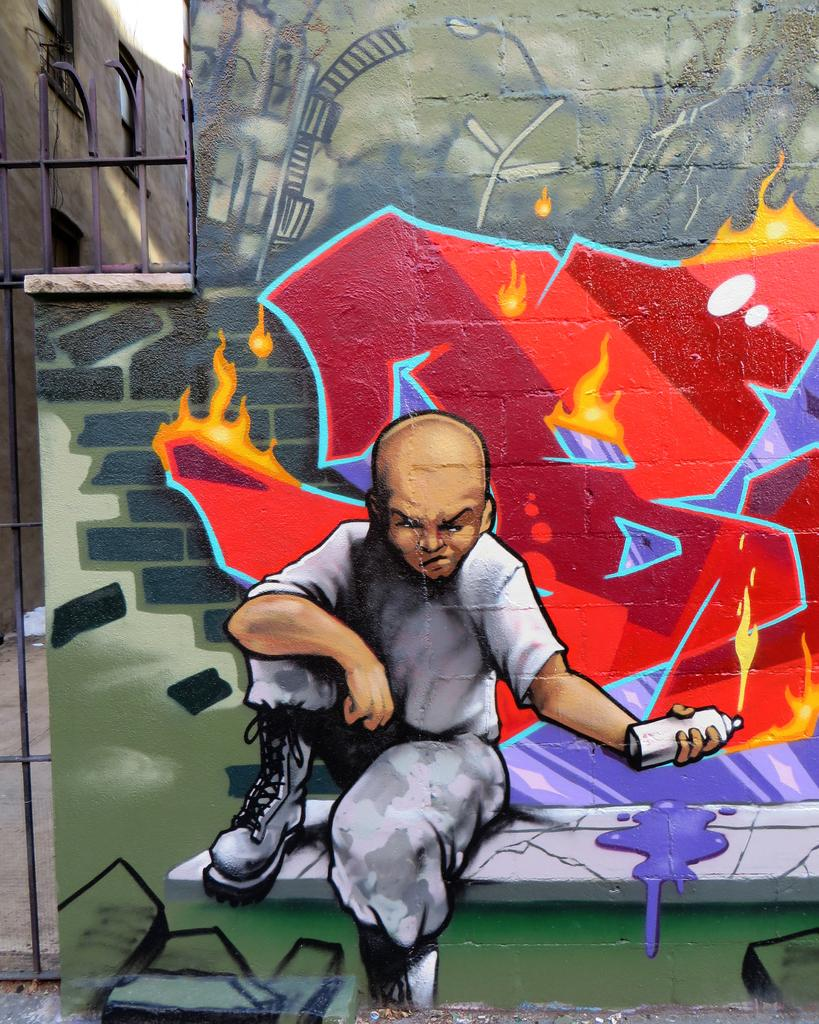What is depicted on the wall in the image? There is graffiti on a wall in the image. What is the graffiti's subject matter? The graffiti appears to depict a man sitting on a bench. Is there any additional feature on the wall besides the graffiti? Yes, there is a fence on the wall to the left. What type of copper material can be seen on the stage in the image? There is no stage or copper material present in the image; it features graffiti on a wall with a fence on the left. 